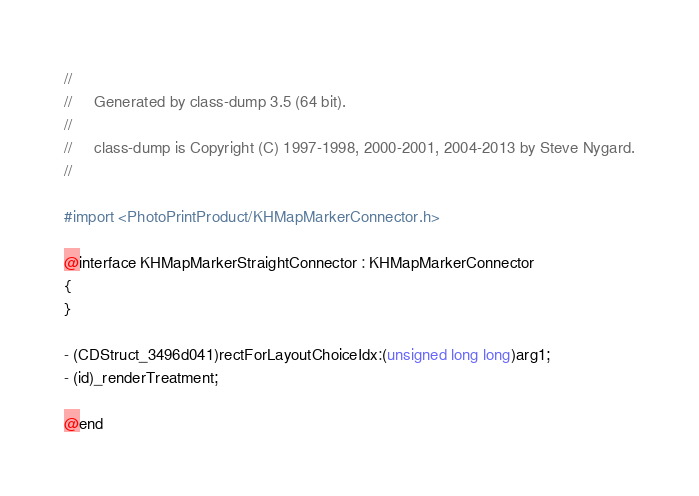<code> <loc_0><loc_0><loc_500><loc_500><_C_>//
//     Generated by class-dump 3.5 (64 bit).
//
//     class-dump is Copyright (C) 1997-1998, 2000-2001, 2004-2013 by Steve Nygard.
//

#import <PhotoPrintProduct/KHMapMarkerConnector.h>

@interface KHMapMarkerStraightConnector : KHMapMarkerConnector
{
}

- (CDStruct_3496d041)rectForLayoutChoiceIdx:(unsigned long long)arg1;
- (id)_renderTreatment;

@end

</code> 